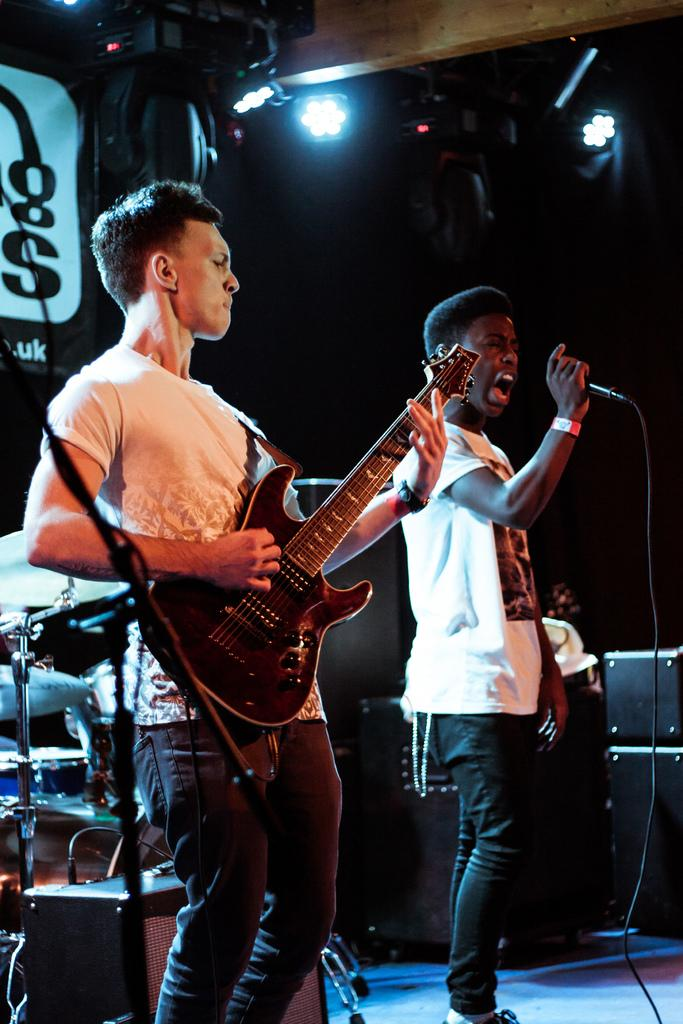What is the man in the image doing? The man is playing a guitar in the image. How is the man's voice being amplified? The man is singing through a microphone. What musical instruments can be seen in the background? There are electronic drums in the background. What equipment is used for sound amplification in the image? There are speakers in the background. What type of lighting is present in the background? Show lights are present in the background. What type of fowl is present in the image? There is no fowl present in the image. What type of medical assistance is the man receiving in the image? The man is not receiving any medical assistance in the image; he is playing a guitar and singing. 